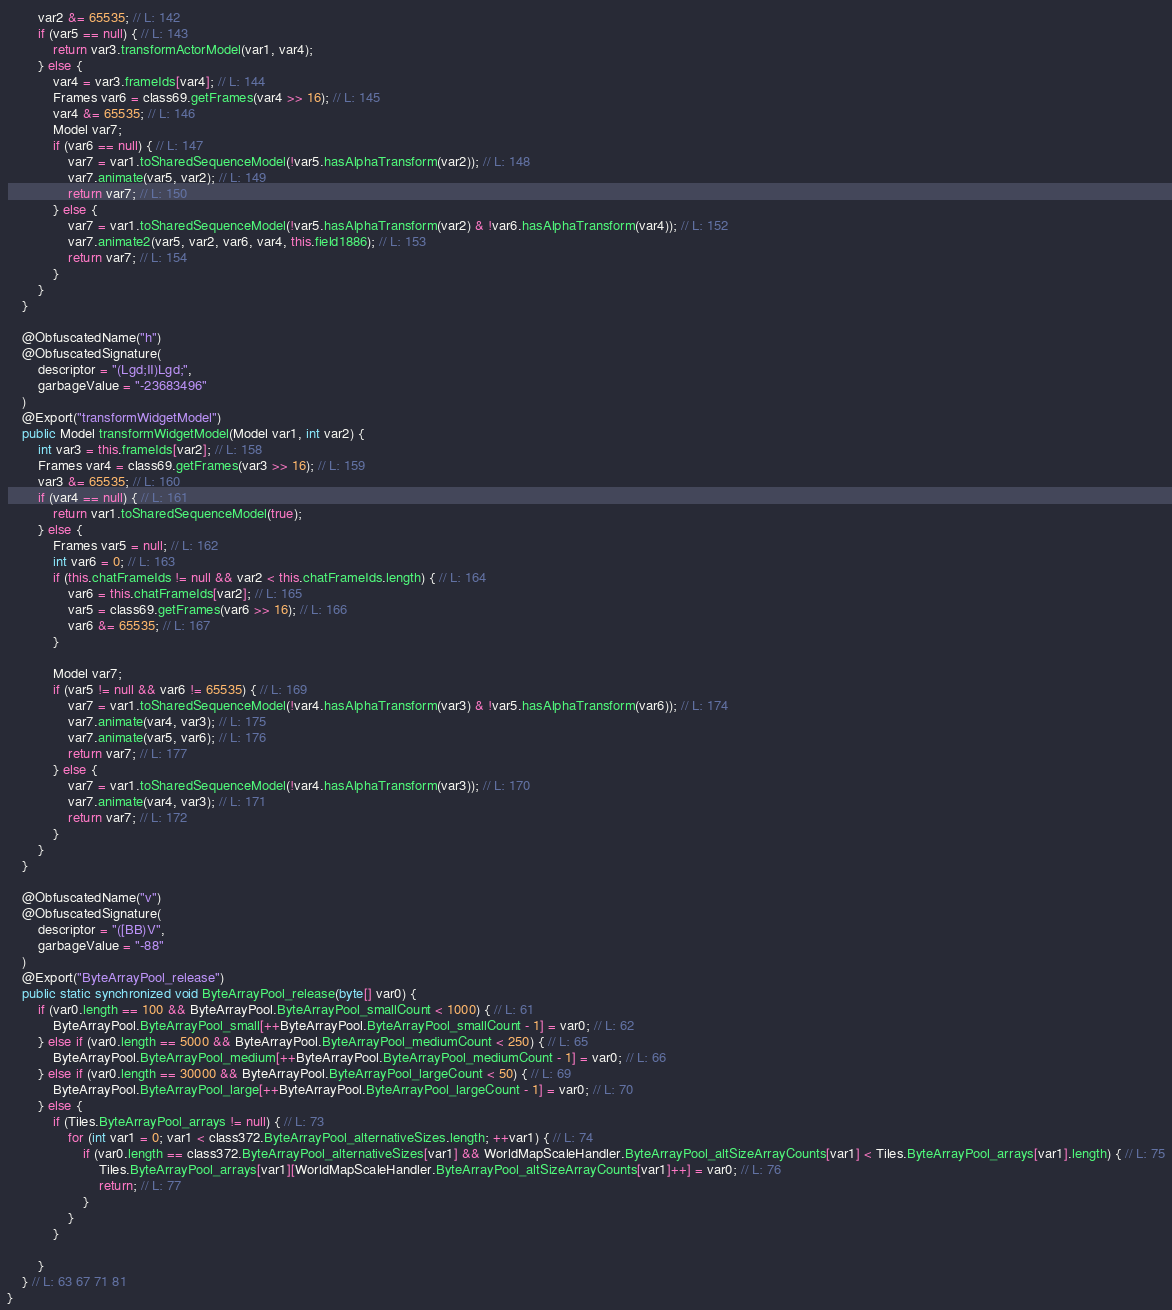Convert code to text. <code><loc_0><loc_0><loc_500><loc_500><_Java_>		var2 &= 65535; // L: 142
		if (var5 == null) { // L: 143
			return var3.transformActorModel(var1, var4);
		} else {
			var4 = var3.frameIds[var4]; // L: 144
			Frames var6 = class69.getFrames(var4 >> 16); // L: 145
			var4 &= 65535; // L: 146
			Model var7;
			if (var6 == null) { // L: 147
				var7 = var1.toSharedSequenceModel(!var5.hasAlphaTransform(var2)); // L: 148
				var7.animate(var5, var2); // L: 149
				return var7; // L: 150
			} else {
				var7 = var1.toSharedSequenceModel(!var5.hasAlphaTransform(var2) & !var6.hasAlphaTransform(var4)); // L: 152
				var7.animate2(var5, var2, var6, var4, this.field1886); // L: 153
				return var7; // L: 154
			}
		}
	}

	@ObfuscatedName("h")
	@ObfuscatedSignature(
		descriptor = "(Lgd;II)Lgd;",
		garbageValue = "-23683496"
	)
	@Export("transformWidgetModel")
	public Model transformWidgetModel(Model var1, int var2) {
		int var3 = this.frameIds[var2]; // L: 158
		Frames var4 = class69.getFrames(var3 >> 16); // L: 159
		var3 &= 65535; // L: 160
		if (var4 == null) { // L: 161
			return var1.toSharedSequenceModel(true);
		} else {
			Frames var5 = null; // L: 162
			int var6 = 0; // L: 163
			if (this.chatFrameIds != null && var2 < this.chatFrameIds.length) { // L: 164
				var6 = this.chatFrameIds[var2]; // L: 165
				var5 = class69.getFrames(var6 >> 16); // L: 166
				var6 &= 65535; // L: 167
			}

			Model var7;
			if (var5 != null && var6 != 65535) { // L: 169
				var7 = var1.toSharedSequenceModel(!var4.hasAlphaTransform(var3) & !var5.hasAlphaTransform(var6)); // L: 174
				var7.animate(var4, var3); // L: 175
				var7.animate(var5, var6); // L: 176
				return var7; // L: 177
			} else {
				var7 = var1.toSharedSequenceModel(!var4.hasAlphaTransform(var3)); // L: 170
				var7.animate(var4, var3); // L: 171
				return var7; // L: 172
			}
		}
	}

	@ObfuscatedName("v")
	@ObfuscatedSignature(
		descriptor = "([BB)V",
		garbageValue = "-88"
	)
	@Export("ByteArrayPool_release")
	public static synchronized void ByteArrayPool_release(byte[] var0) {
		if (var0.length == 100 && ByteArrayPool.ByteArrayPool_smallCount < 1000) { // L: 61
			ByteArrayPool.ByteArrayPool_small[++ByteArrayPool.ByteArrayPool_smallCount - 1] = var0; // L: 62
		} else if (var0.length == 5000 && ByteArrayPool.ByteArrayPool_mediumCount < 250) { // L: 65
			ByteArrayPool.ByteArrayPool_medium[++ByteArrayPool.ByteArrayPool_mediumCount - 1] = var0; // L: 66
		} else if (var0.length == 30000 && ByteArrayPool.ByteArrayPool_largeCount < 50) { // L: 69
			ByteArrayPool.ByteArrayPool_large[++ByteArrayPool.ByteArrayPool_largeCount - 1] = var0; // L: 70
		} else {
			if (Tiles.ByteArrayPool_arrays != null) { // L: 73
				for (int var1 = 0; var1 < class372.ByteArrayPool_alternativeSizes.length; ++var1) { // L: 74
					if (var0.length == class372.ByteArrayPool_alternativeSizes[var1] && WorldMapScaleHandler.ByteArrayPool_altSizeArrayCounts[var1] < Tiles.ByteArrayPool_arrays[var1].length) { // L: 75
						Tiles.ByteArrayPool_arrays[var1][WorldMapScaleHandler.ByteArrayPool_altSizeArrayCounts[var1]++] = var0; // L: 76
						return; // L: 77
					}
				}
			}

		}
	} // L: 63 67 71 81
}
</code> 